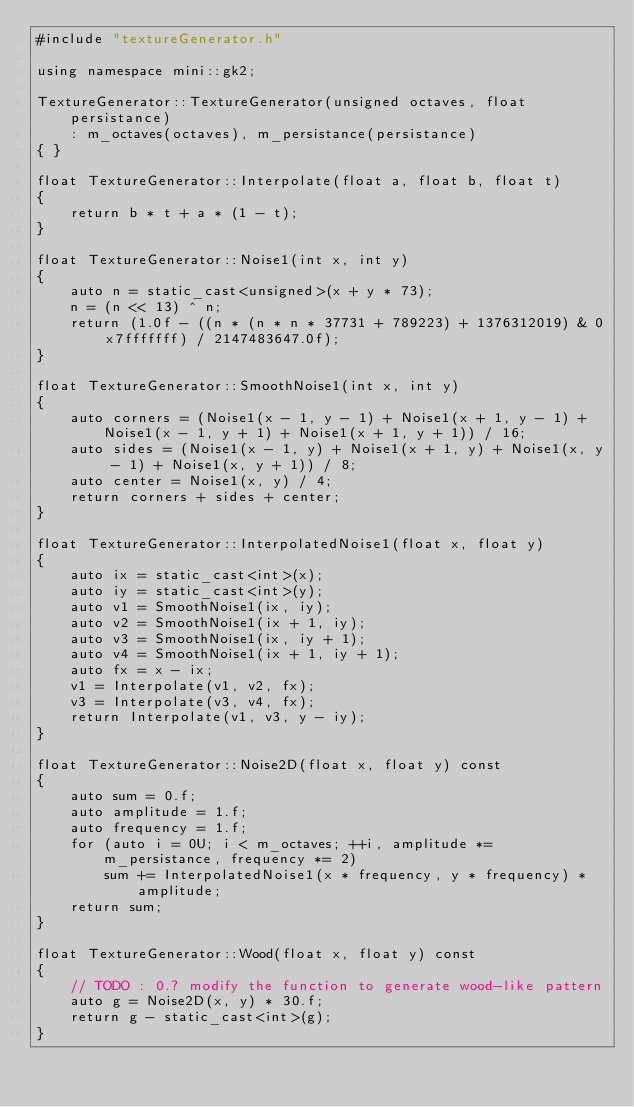Convert code to text. <code><loc_0><loc_0><loc_500><loc_500><_C++_>#include "textureGenerator.h"

using namespace mini::gk2;

TextureGenerator::TextureGenerator(unsigned octaves, float persistance)
	: m_octaves(octaves), m_persistance(persistance)
{ }

float TextureGenerator::Interpolate(float a, float b, float t)
{
	return b * t + a * (1 - t);
}

float TextureGenerator::Noise1(int x, int y)
{
	auto n = static_cast<unsigned>(x + y * 73);
	n = (n << 13) ^ n;
	return (1.0f - ((n * (n * n * 37731 + 789223) + 1376312019) & 0x7fffffff) / 2147483647.0f);
}

float TextureGenerator::SmoothNoise1(int x, int y)
{
	auto corners = (Noise1(x - 1, y - 1) + Noise1(x + 1, y - 1) + Noise1(x - 1, y + 1) + Noise1(x + 1, y + 1)) / 16;
	auto sides = (Noise1(x - 1, y) + Noise1(x + 1, y) + Noise1(x, y - 1) + Noise1(x, y + 1)) / 8;
	auto center = Noise1(x, y) / 4;
	return corners + sides + center;
}

float TextureGenerator::InterpolatedNoise1(float x, float y)
{
	auto ix = static_cast<int>(x);
	auto iy = static_cast<int>(y);
	auto v1 = SmoothNoise1(ix, iy);
	auto v2 = SmoothNoise1(ix + 1, iy);
	auto v3 = SmoothNoise1(ix, iy + 1);
	auto v4 = SmoothNoise1(ix + 1, iy + 1);
	auto fx = x - ix;
	v1 = Interpolate(v1, v2, fx);
	v3 = Interpolate(v3, v4, fx);
	return Interpolate(v1, v3, y - iy);
}

float TextureGenerator::Noise2D(float x, float y) const
{
	auto sum = 0.f;
	auto amplitude = 1.f;
	auto frequency = 1.f;
	for (auto i = 0U; i < m_octaves; ++i, amplitude *= m_persistance, frequency *= 2)
		sum += InterpolatedNoise1(x * frequency, y * frequency) * amplitude;
	return sum;
}

float TextureGenerator::Wood(float x, float y) const
{
	// TODO : 0.? modify the function to generate wood-like pattern
	auto g = Noise2D(x, y) * 30.f;
	return g - static_cast<int>(g);
}</code> 